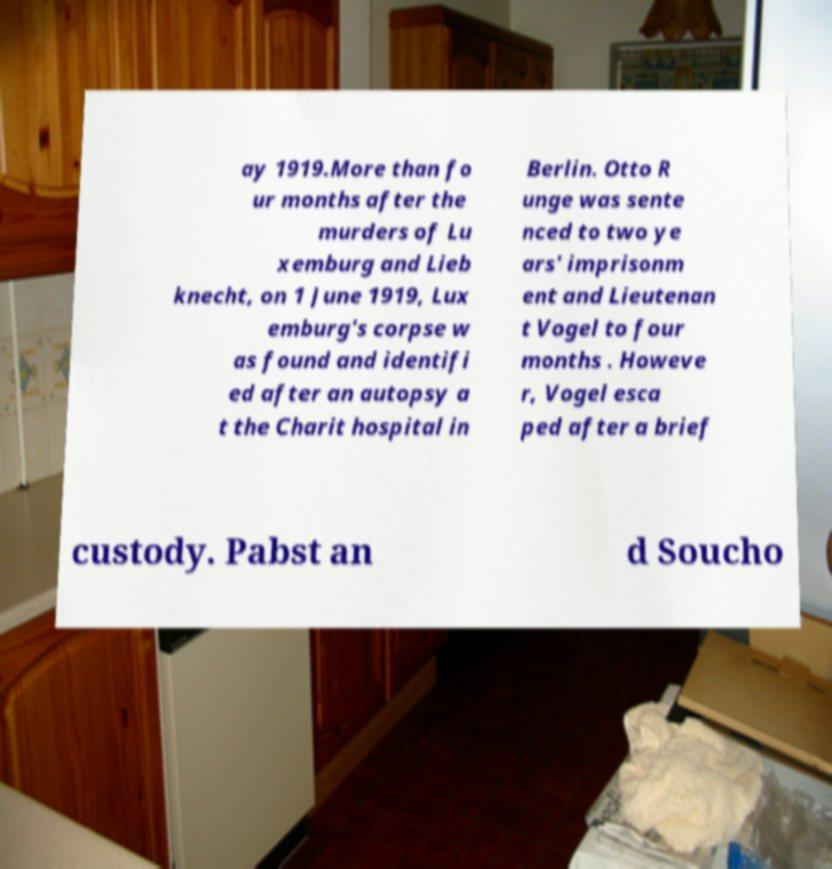Please read and relay the text visible in this image. What does it say? ay 1919.More than fo ur months after the murders of Lu xemburg and Lieb knecht, on 1 June 1919, Lux emburg's corpse w as found and identifi ed after an autopsy a t the Charit hospital in Berlin. Otto R unge was sente nced to two ye ars' imprisonm ent and Lieutenan t Vogel to four months . Howeve r, Vogel esca ped after a brief custody. Pabst an d Soucho 